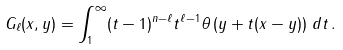<formula> <loc_0><loc_0><loc_500><loc_500>G _ { \ell } ( x , y ) = \int _ { 1 } ^ { \infty } ( t - 1 ) ^ { n - \ell } t ^ { \ell - 1 } \theta \left ( y + t ( x - y ) \right ) \, d t \, .</formula> 